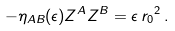<formula> <loc_0><loc_0><loc_500><loc_500>- \eta _ { A B } ( \epsilon ) Z ^ { A } Z ^ { B } = \epsilon \, { r _ { 0 } } ^ { 2 } \, .</formula> 